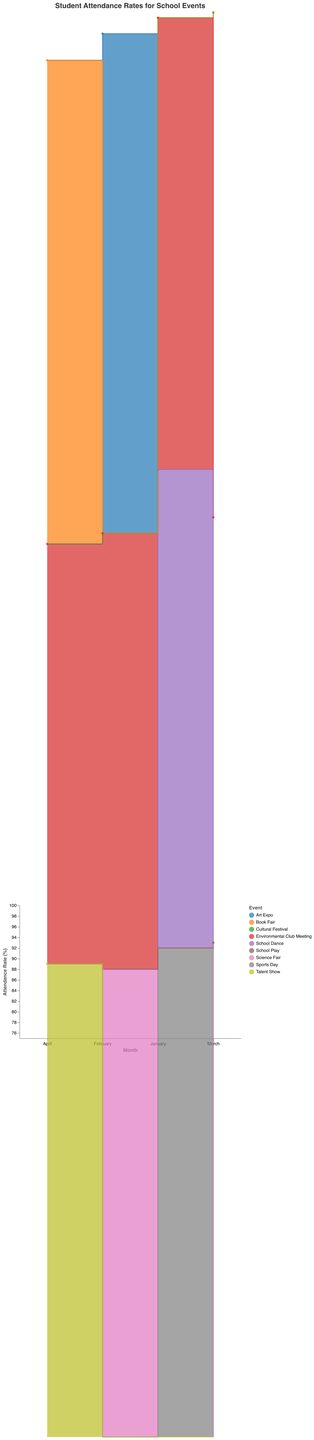What event had the highest attendance rate in January? To find the highest attendance rate in January, look for the events in January: Sports Day (92%), Environmental Club Meeting (85%), and School Dance (90%). The highest among these is 92% for Sports Day.
Answer: Sports Day What is the attendance rate difference between the Cultural Festival in March and the Environmental Club Meeting in March? First, identify the attendance rates for both events in March: Cultural Festival (95%) and Environmental Club Meeting (80%). The difference is 95% - 80% = 15%.
Answer: 15% Which month had the lowest attendance rate for Environmental Club Meetings? Compare the attendance rates of Environmental Club Meetings over the months: January (85%), February (82%), March (80%), and April (79%). The lowest rate is in April at 79%.
Answer: April How many data points are there in the visualized data? Count the number of events listed across all months: 12 events.
Answer: 12 What's the average attendance rate for all events in April? Identify the events in April: Book Fair (91%), Environmental Club Meeting (79%), and Talent Show (89%). Sum the rates: 91% + 79% + 89% = 259%. Divide by the number of events, which is 3: 259% / 3 = 86.33%.
Answer: 86.33% Which event had the most stable (least varied) attendance rate month over month? Evaluate the attendance rates of each event: Environmental Club Meeting shows a steady decline (85%, 82%, 80%, 79%), which is more stable compared to the others with larger fluctuations.
Answer: Environmental Club Meeting Is there an event type that consistently has lower attendance rates? Look at the pattern of attendance rates for all events. The Environmental Club Meeting consistently has the lowest rates across months: January (85%), February (82%), March (80%), and April (79%).
Answer: Environmental Club Meeting What is the difference between the highest and lowest attendance rates in the entire dataset? Find the highest rate: Cultural Festival in March (95%). Find the lowest rate: Environmental Club Meeting in April (79%). The difference is 95% - 79% = 16%.
Answer: 16% 